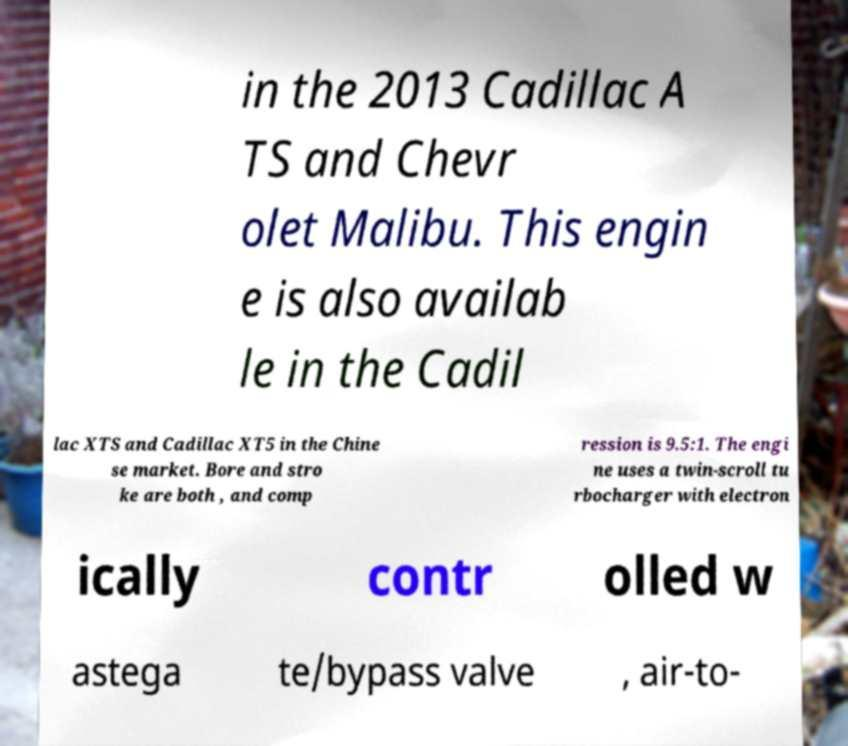Could you extract and type out the text from this image? in the 2013 Cadillac A TS and Chevr olet Malibu. This engin e is also availab le in the Cadil lac XTS and Cadillac XT5 in the Chine se market. Bore and stro ke are both , and comp ression is 9.5:1. The engi ne uses a twin-scroll tu rbocharger with electron ically contr olled w astega te/bypass valve , air-to- 